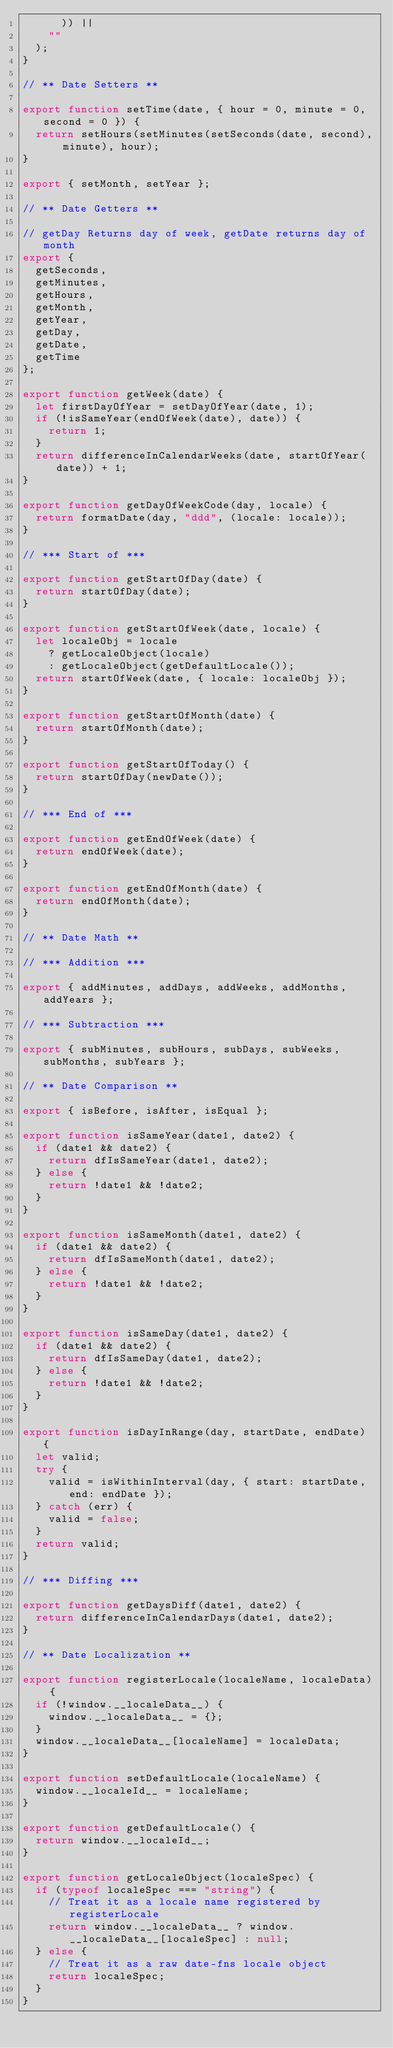Convert code to text. <code><loc_0><loc_0><loc_500><loc_500><_JavaScript_>      )) ||
    ""
  );
}

// ** Date Setters **

export function setTime(date, { hour = 0, minute = 0, second = 0 }) {
  return setHours(setMinutes(setSeconds(date, second), minute), hour);
}

export { setMonth, setYear };

// ** Date Getters **

// getDay Returns day of week, getDate returns day of month
export {
  getSeconds,
  getMinutes,
  getHours,
  getMonth,
  getYear,
  getDay,
  getDate,
  getTime
};

export function getWeek(date) {
  let firstDayOfYear = setDayOfYear(date, 1);
  if (!isSameYear(endOfWeek(date), date)) {
    return 1;
  }
  return differenceInCalendarWeeks(date, startOfYear(date)) + 1;
}

export function getDayOfWeekCode(day, locale) {
  return formatDate(day, "ddd", (locale: locale));
}

// *** Start of ***

export function getStartOfDay(date) {
  return startOfDay(date);
}

export function getStartOfWeek(date, locale) {
  let localeObj = locale
    ? getLocaleObject(locale)
    : getLocaleObject(getDefaultLocale());
  return startOfWeek(date, { locale: localeObj });
}

export function getStartOfMonth(date) {
  return startOfMonth(date);
}

export function getStartOfToday() {
  return startOfDay(newDate());
}

// *** End of ***

export function getEndOfWeek(date) {
  return endOfWeek(date);
}

export function getEndOfMonth(date) {
  return endOfMonth(date);
}

// ** Date Math **

// *** Addition ***

export { addMinutes, addDays, addWeeks, addMonths, addYears };

// *** Subtraction ***

export { subMinutes, subHours, subDays, subWeeks, subMonths, subYears };

// ** Date Comparison **

export { isBefore, isAfter, isEqual };

export function isSameYear(date1, date2) {
  if (date1 && date2) {
    return dfIsSameYear(date1, date2);
  } else {
    return !date1 && !date2;
  }
}

export function isSameMonth(date1, date2) {
  if (date1 && date2) {
    return dfIsSameMonth(date1, date2);
  } else {
    return !date1 && !date2;
  }
}

export function isSameDay(date1, date2) {
  if (date1 && date2) {
    return dfIsSameDay(date1, date2);
  } else {
    return !date1 && !date2;
  }
}

export function isDayInRange(day, startDate, endDate) {
  let valid;
  try {
    valid = isWithinInterval(day, { start: startDate, end: endDate });
  } catch (err) {
    valid = false;
  }
  return valid;
}

// *** Diffing ***

export function getDaysDiff(date1, date2) {
  return differenceInCalendarDays(date1, date2);
}

// ** Date Localization **

export function registerLocale(localeName, localeData) {
  if (!window.__localeData__) {
    window.__localeData__ = {};
  }
  window.__localeData__[localeName] = localeData;
}

export function setDefaultLocale(localeName) {
  window.__localeId__ = localeName;
}

export function getDefaultLocale() {
  return window.__localeId__;
}

export function getLocaleObject(localeSpec) {
  if (typeof localeSpec === "string") {
    // Treat it as a locale name registered by registerLocale
    return window.__localeData__ ? window.__localeData__[localeSpec] : null;
  } else {
    // Treat it as a raw date-fns locale object
    return localeSpec;
  }
}
</code> 